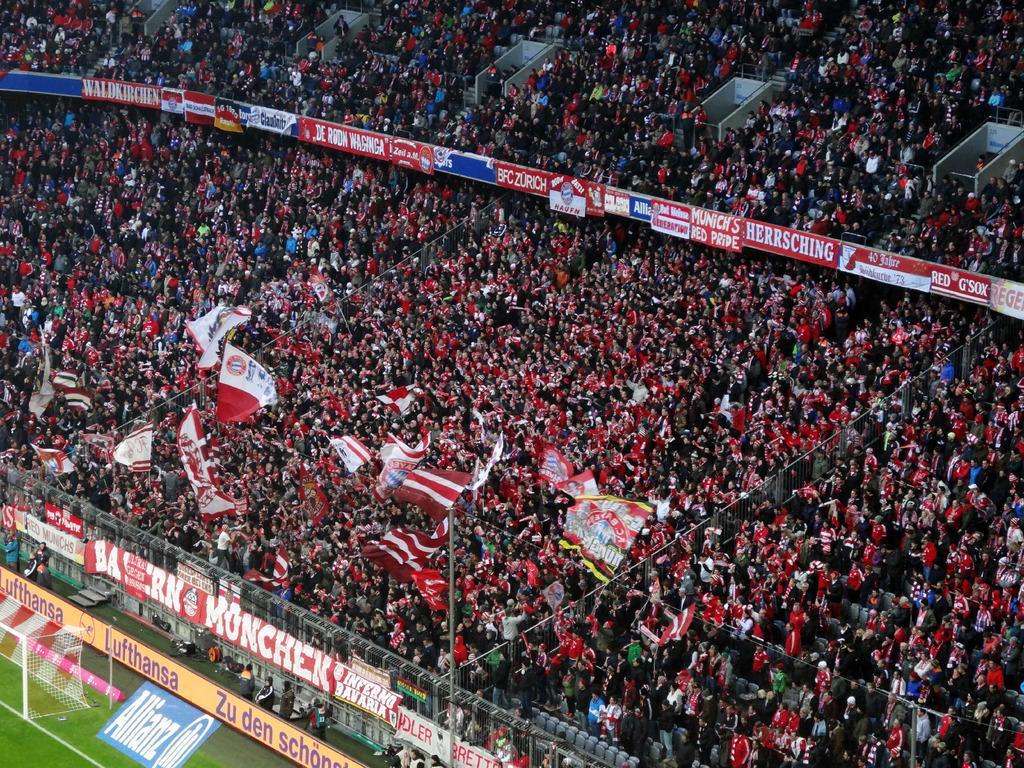Please provide a concise description of this image. In this I can see number of people, number of boards and few flags. On the bottom left side of this image I can see a goal post and I can also see somethings is written on these boards. 